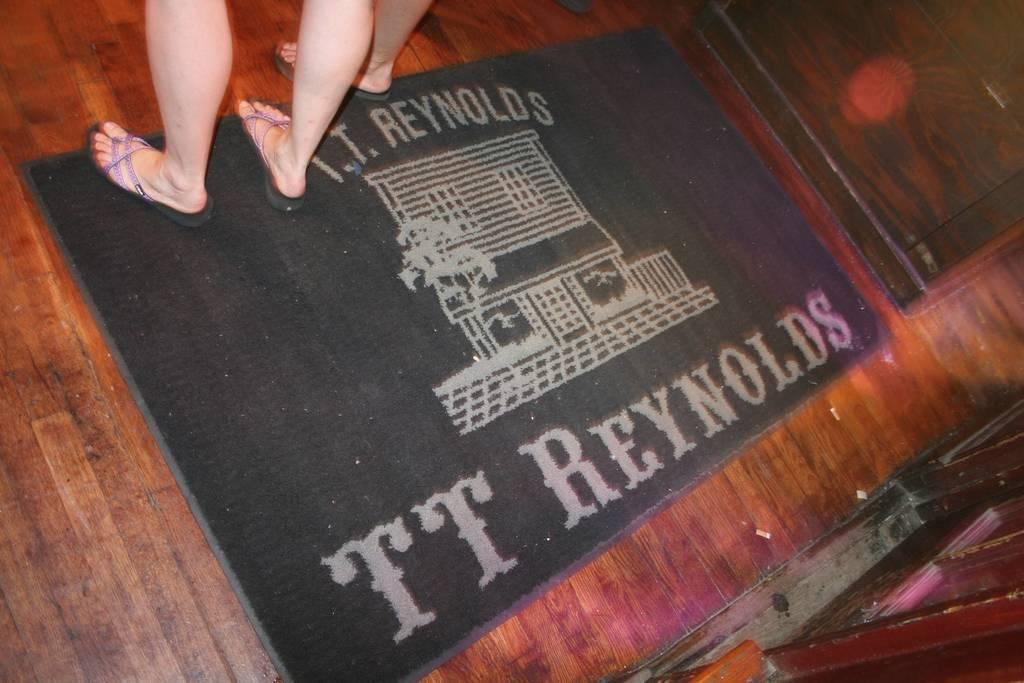What can be seen at the bottom of the image? There is wooden flooring at the bottom of the image. What type of surface is the legs of people standing on? The legs are on a carpet. Can you describe the legs of people visible in the image? The legs are visible, but no other details about them can be determined from the provided facts. How many balls are being served by the servant in the image? There is no servant or balls present in the image. What type of friction is present between the legs and the carpet in the image? The provided facts do not give enough information to determine the type of friction between the legs and the carpet. 